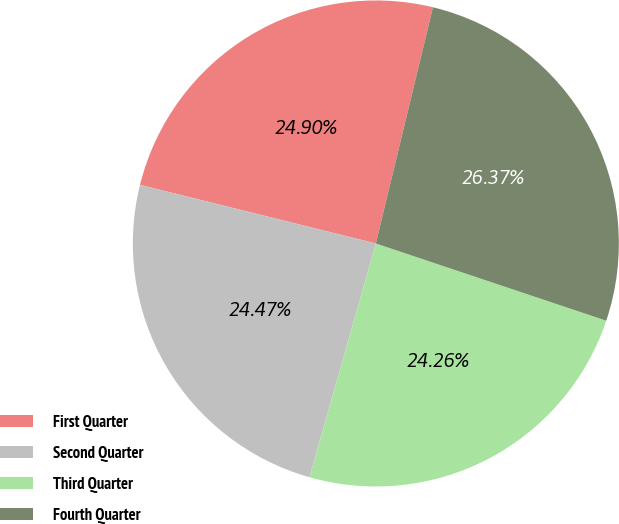Convert chart. <chart><loc_0><loc_0><loc_500><loc_500><pie_chart><fcel>First Quarter<fcel>Second Quarter<fcel>Third Quarter<fcel>Fourth Quarter<nl><fcel>24.9%<fcel>24.47%<fcel>24.26%<fcel>26.37%<nl></chart> 